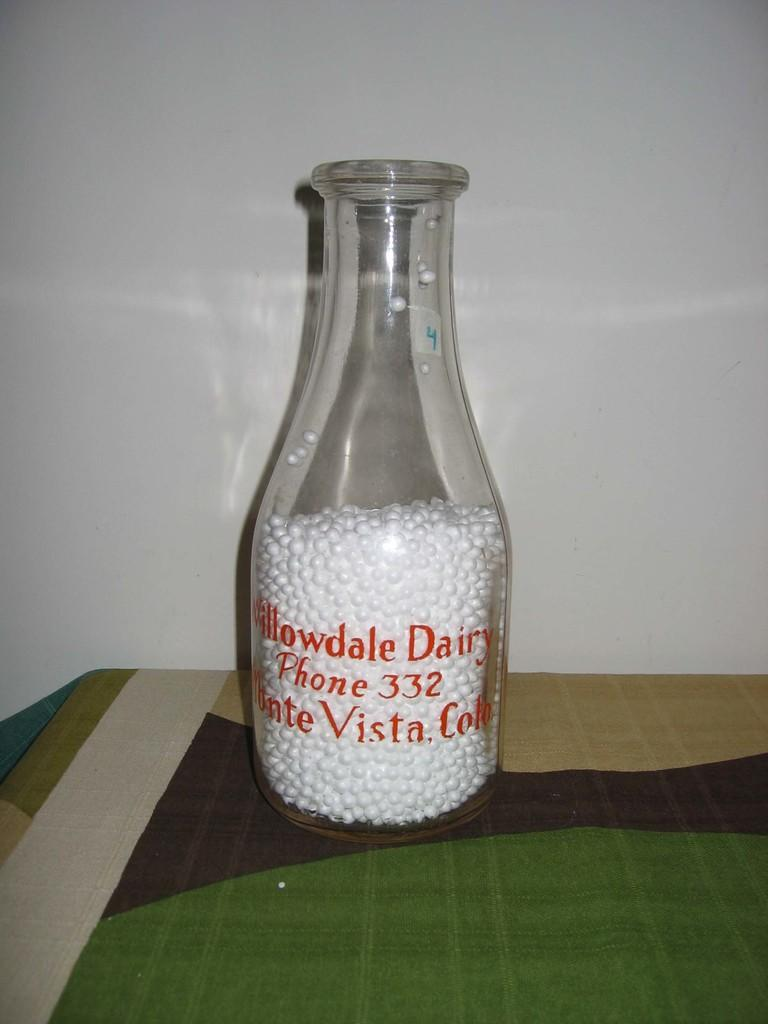What object is on the table in the image? There is a bottle on the table in the image. What is inside the bottle? The bottle contains thermocol balls. What type of cable is connected to the goat in the image? There is no goat or cable present in the image. 